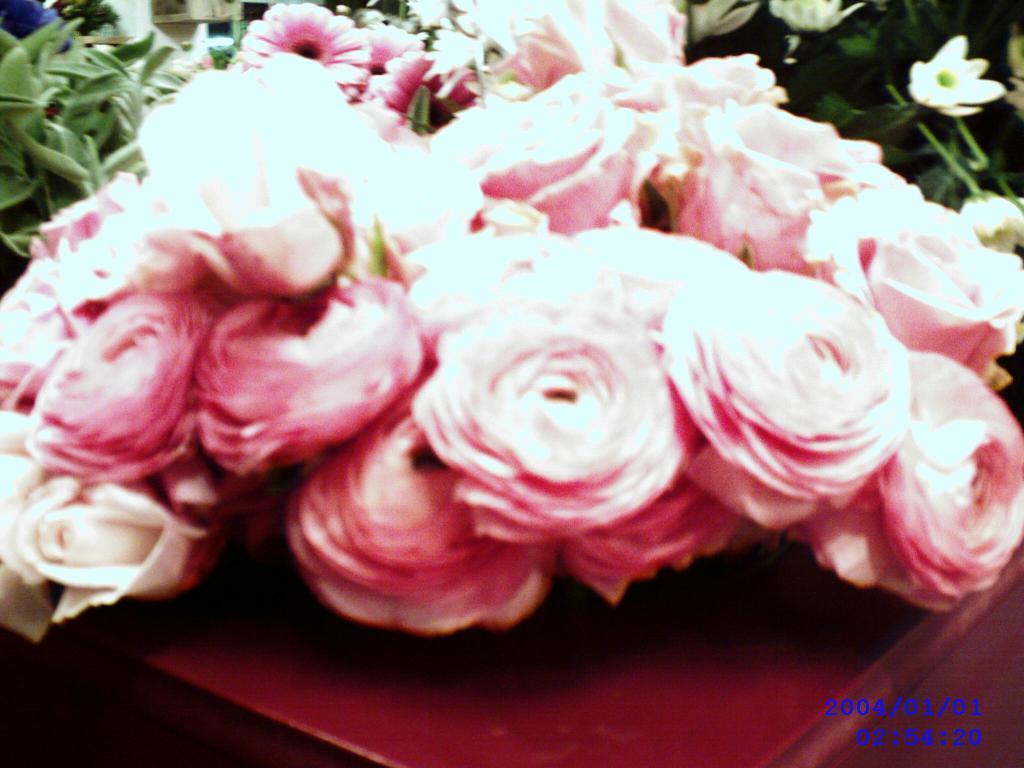Please provide a concise description of this image. In this image I can see number of flowers and on the both side of it I can see green colour leaves. I can also see a watermark on the bottom right side of this image. 